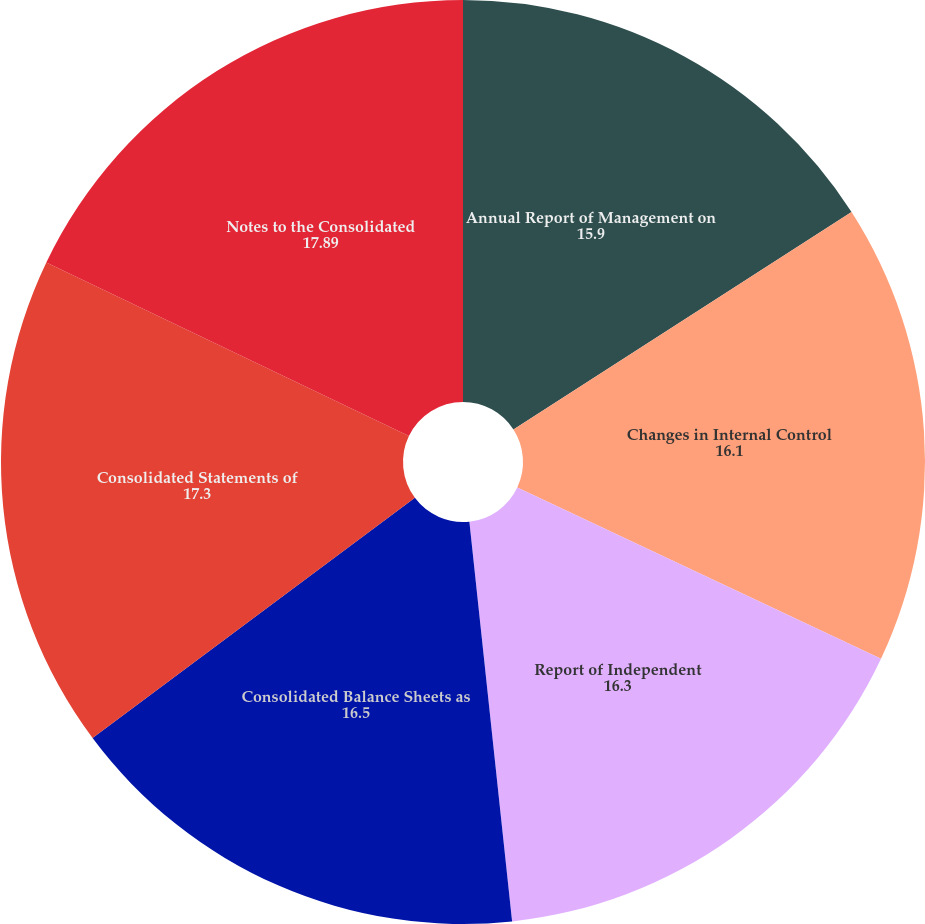Convert chart to OTSL. <chart><loc_0><loc_0><loc_500><loc_500><pie_chart><fcel>Annual Report of Management on<fcel>Changes in Internal Control<fcel>Report of Independent<fcel>Consolidated Balance Sheets as<fcel>Consolidated Statements of<fcel>Notes to the Consolidated<nl><fcel>15.9%<fcel>16.1%<fcel>16.3%<fcel>16.5%<fcel>17.3%<fcel>17.89%<nl></chart> 